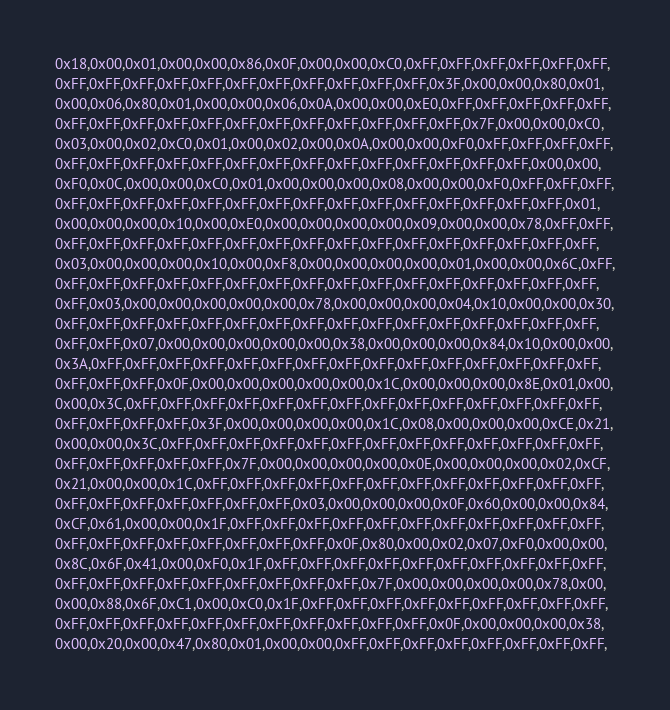<code> <loc_0><loc_0><loc_500><loc_500><_C_>0x18,0x00,0x01,0x00,0x00,0x86,0x0F,0x00,0x00,0xC0,0xFF,0xFF,0xFF,0xFF,0xFF,0xFF,
0xFF,0xFF,0xFF,0xFF,0xFF,0xFF,0xFF,0xFF,0xFF,0xFF,0xFF,0x3F,0x00,0x00,0x80,0x01,
0x00,0x06,0x80,0x01,0x00,0x00,0x06,0x0A,0x00,0x00,0xE0,0xFF,0xFF,0xFF,0xFF,0xFF,
0xFF,0xFF,0xFF,0xFF,0xFF,0xFF,0xFF,0xFF,0xFF,0xFF,0xFF,0xFF,0x7F,0x00,0x00,0xC0,
0x03,0x00,0x02,0xC0,0x01,0x00,0x02,0x00,0x0A,0x00,0x00,0xF0,0xFF,0xFF,0xFF,0xFF,
0xFF,0xFF,0xFF,0xFF,0xFF,0xFF,0xFF,0xFF,0xFF,0xFF,0xFF,0xFF,0xFF,0xFF,0x00,0x00,
0xF0,0x0C,0x00,0x00,0xC0,0x01,0x00,0x00,0x00,0x08,0x00,0x00,0xF0,0xFF,0xFF,0xFF,
0xFF,0xFF,0xFF,0xFF,0xFF,0xFF,0xFF,0xFF,0xFF,0xFF,0xFF,0xFF,0xFF,0xFF,0xFF,0x01,
0x00,0x00,0x00,0x10,0x00,0xE0,0x00,0x00,0x00,0x00,0x09,0x00,0x00,0x78,0xFF,0xFF,
0xFF,0xFF,0xFF,0xFF,0xFF,0xFF,0xFF,0xFF,0xFF,0xFF,0xFF,0xFF,0xFF,0xFF,0xFF,0xFF,
0x03,0x00,0x00,0x00,0x10,0x00,0xF8,0x00,0x00,0x00,0x00,0x01,0x00,0x00,0x6C,0xFF,
0xFF,0xFF,0xFF,0xFF,0xFF,0xFF,0xFF,0xFF,0xFF,0xFF,0xFF,0xFF,0xFF,0xFF,0xFF,0xFF,
0xFF,0x03,0x00,0x00,0x00,0x00,0x00,0x78,0x00,0x00,0x00,0x04,0x10,0x00,0x00,0x30,
0xFF,0xFF,0xFF,0xFF,0xFF,0xFF,0xFF,0xFF,0xFF,0xFF,0xFF,0xFF,0xFF,0xFF,0xFF,0xFF,
0xFF,0xFF,0x07,0x00,0x00,0x00,0x00,0x00,0x38,0x00,0x00,0x00,0x84,0x10,0x00,0x00,
0x3A,0xFF,0xFF,0xFF,0xFF,0xFF,0xFF,0xFF,0xFF,0xFF,0xFF,0xFF,0xFF,0xFF,0xFF,0xFF,
0xFF,0xFF,0xFF,0x0F,0x00,0x00,0x00,0x00,0x00,0x1C,0x00,0x00,0x00,0x8E,0x01,0x00,
0x00,0x3C,0xFF,0xFF,0xFF,0xFF,0xFF,0xFF,0xFF,0xFF,0xFF,0xFF,0xFF,0xFF,0xFF,0xFF,
0xFF,0xFF,0xFF,0xFF,0x3F,0x00,0x00,0x00,0x00,0x1C,0x08,0x00,0x00,0x00,0xCE,0x21,
0x00,0x00,0x3C,0xFF,0xFF,0xFF,0xFF,0xFF,0xFF,0xFF,0xFF,0xFF,0xFF,0xFF,0xFF,0xFF,
0xFF,0xFF,0xFF,0xFF,0xFF,0x7F,0x00,0x00,0x00,0x00,0x0E,0x00,0x00,0x00,0x02,0xCF,
0x21,0x00,0x00,0x1C,0xFF,0xFF,0xFF,0xFF,0xFF,0xFF,0xFF,0xFF,0xFF,0xFF,0xFF,0xFF,
0xFF,0xFF,0xFF,0xFF,0xFF,0xFF,0xFF,0x03,0x00,0x00,0x00,0x0F,0x60,0x00,0x00,0x84,
0xCF,0x61,0x00,0x00,0x1F,0xFF,0xFF,0xFF,0xFF,0xFF,0xFF,0xFF,0xFF,0xFF,0xFF,0xFF,
0xFF,0xFF,0xFF,0xFF,0xFF,0xFF,0xFF,0xFF,0x0F,0x80,0x00,0x02,0x07,0xF0,0x00,0x00,
0x8C,0x6F,0x41,0x00,0xF0,0x1F,0xFF,0xFF,0xFF,0xFF,0xFF,0xFF,0xFF,0xFF,0xFF,0xFF,
0xFF,0xFF,0xFF,0xFF,0xFF,0xFF,0xFF,0xFF,0xFF,0x7F,0x00,0x00,0x00,0x00,0x78,0x00,
0x00,0x88,0x6F,0xC1,0x00,0xC0,0x1F,0xFF,0xFF,0xFF,0xFF,0xFF,0xFF,0xFF,0xFF,0xFF,
0xFF,0xFF,0xFF,0xFF,0xFF,0xFF,0xFF,0xFF,0xFF,0xFF,0xFF,0x0F,0x00,0x00,0x00,0x38,
0x00,0x20,0x00,0x47,0x80,0x01,0x00,0x00,0xFF,0xFF,0xFF,0xFF,0xFF,0xFF,0xFF,0xFF,</code> 